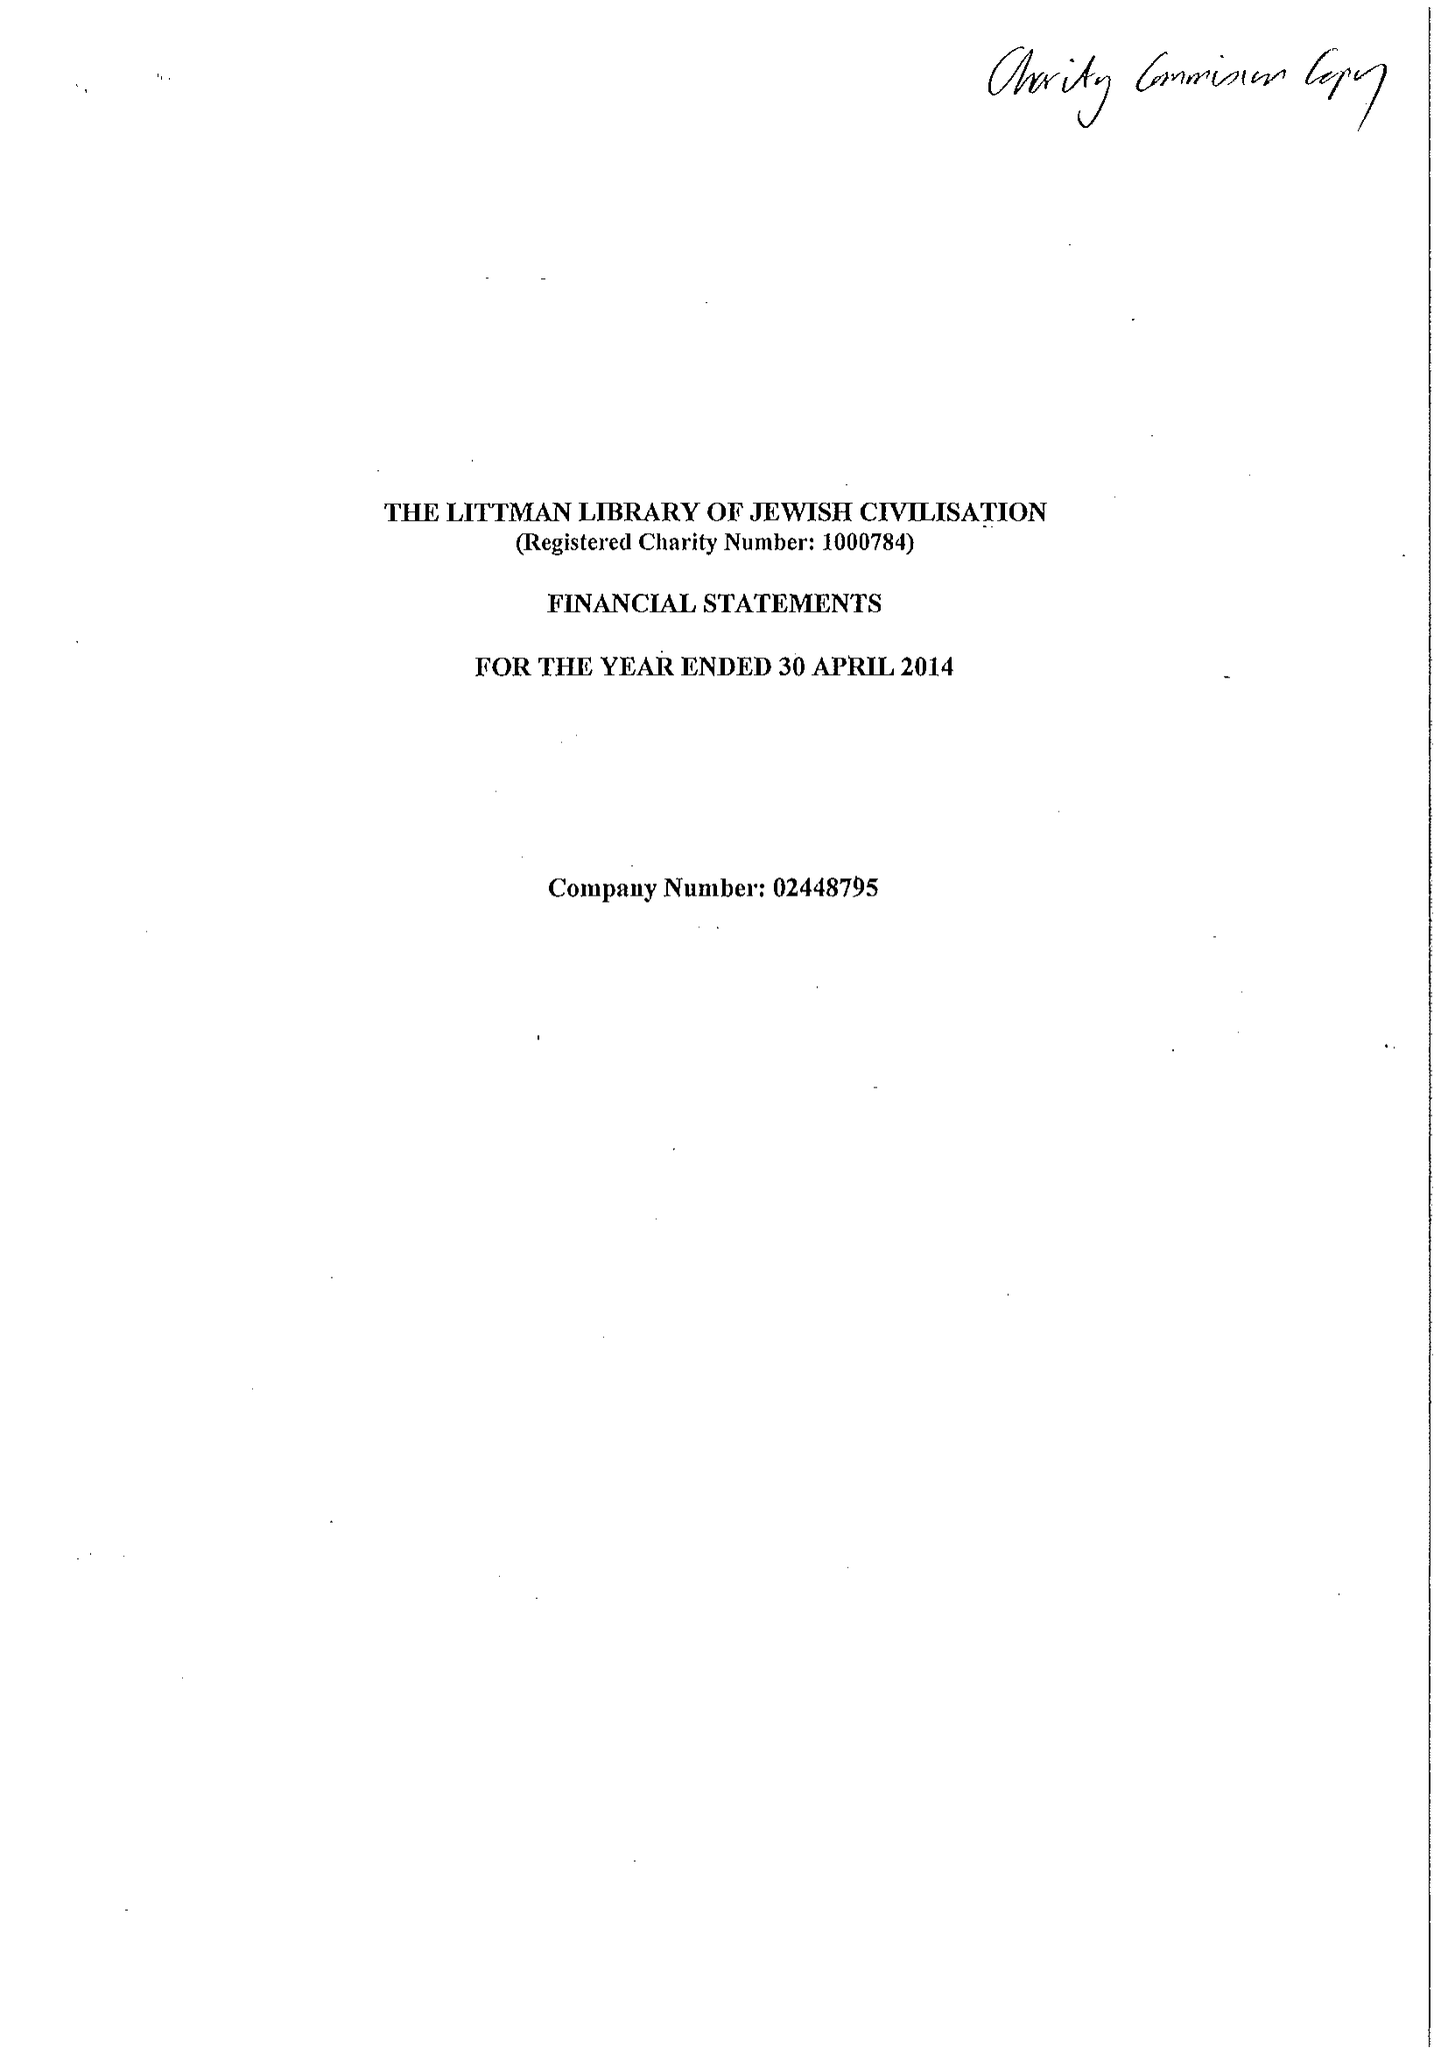What is the value for the income_annually_in_british_pounds?
Answer the question using a single word or phrase. 202754.00 